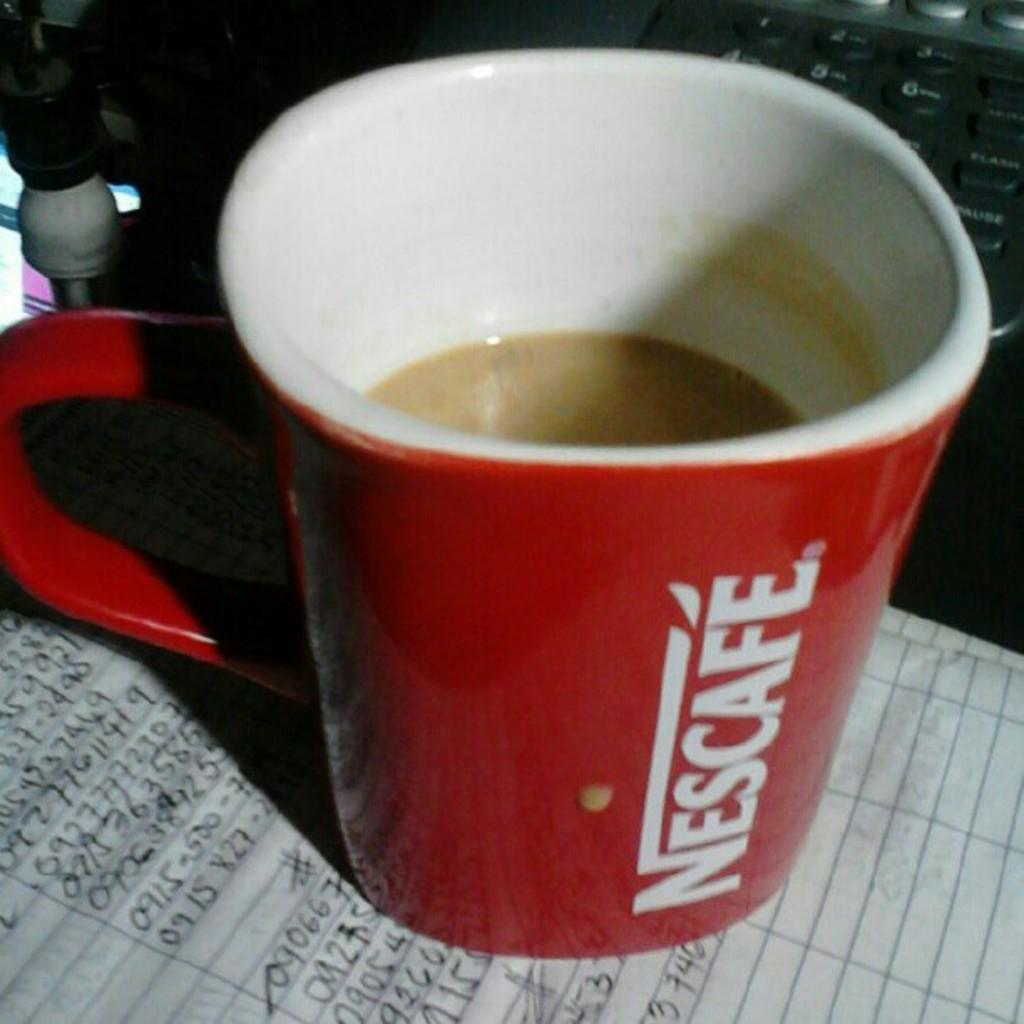<image>
Summarize the visual content of the image. A red nescafe mug is half full and resting on top of a paper. 